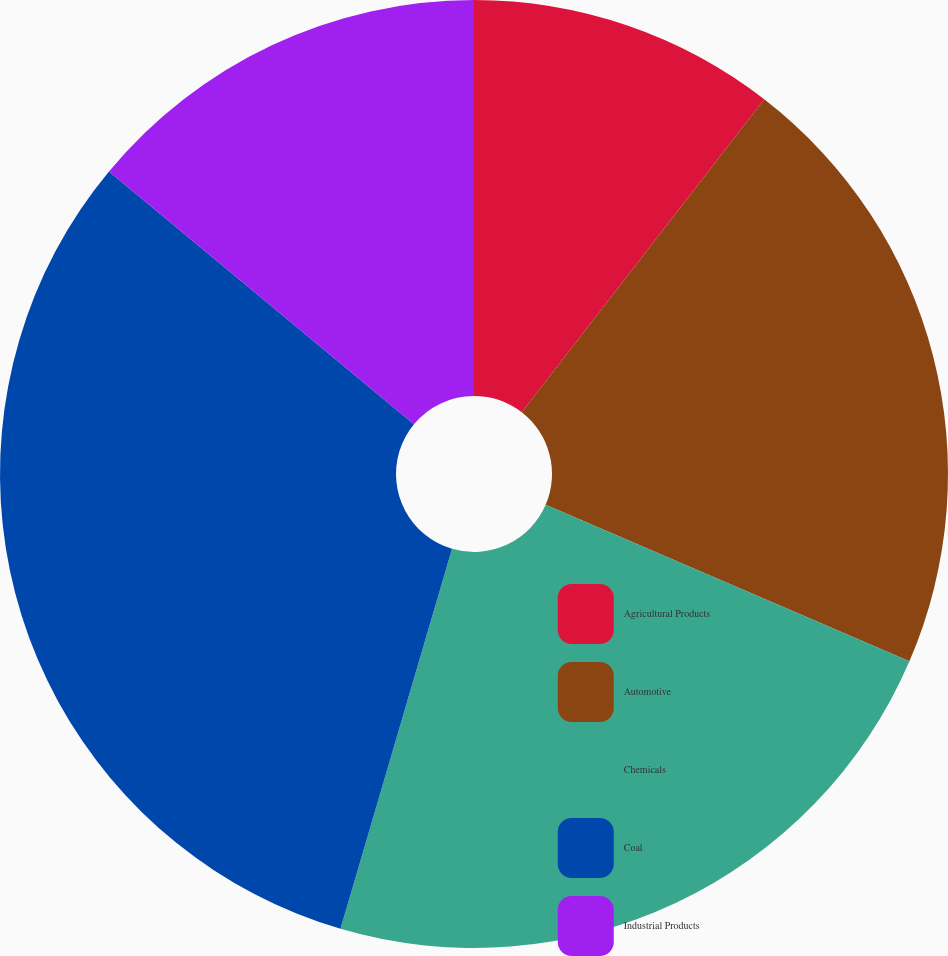Convert chart to OTSL. <chart><loc_0><loc_0><loc_500><loc_500><pie_chart><fcel>Agricultural Products<fcel>Automotive<fcel>Chemicals<fcel>Coal<fcel>Industrial Products<nl><fcel>10.49%<fcel>20.98%<fcel>23.08%<fcel>31.47%<fcel>13.99%<nl></chart> 